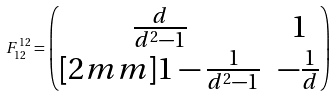Convert formula to latex. <formula><loc_0><loc_0><loc_500><loc_500>F _ { 1 2 } ^ { 1 2 } = \begin{pmatrix} \frac { d } { d ^ { 2 } - 1 } & 1 \\ [ 2 m m ] 1 - \frac { 1 } { d ^ { 2 } - 1 } & - \frac { 1 } { d } \end{pmatrix}</formula> 